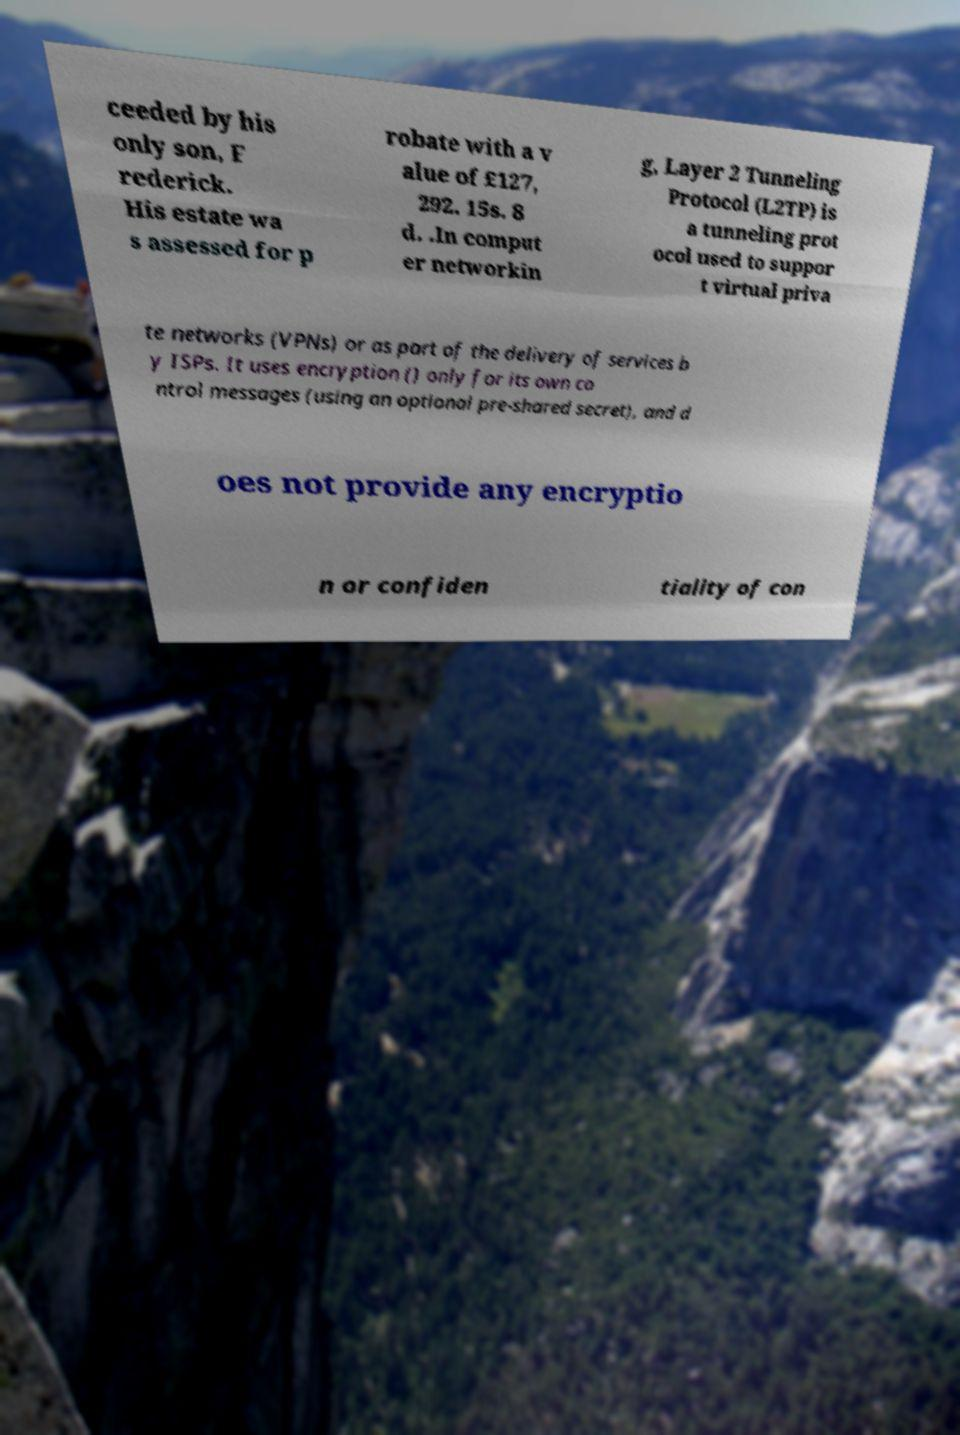What messages or text are displayed in this image? I need them in a readable, typed format. ceeded by his only son, F rederick. His estate wa s assessed for p robate with a v alue of £127, 292. 15s. 8 d. .In comput er networkin g, Layer 2 Tunneling Protocol (L2TP) is a tunneling prot ocol used to suppor t virtual priva te networks (VPNs) or as part of the delivery of services b y ISPs. It uses encryption () only for its own co ntrol messages (using an optional pre-shared secret), and d oes not provide any encryptio n or confiden tiality of con 